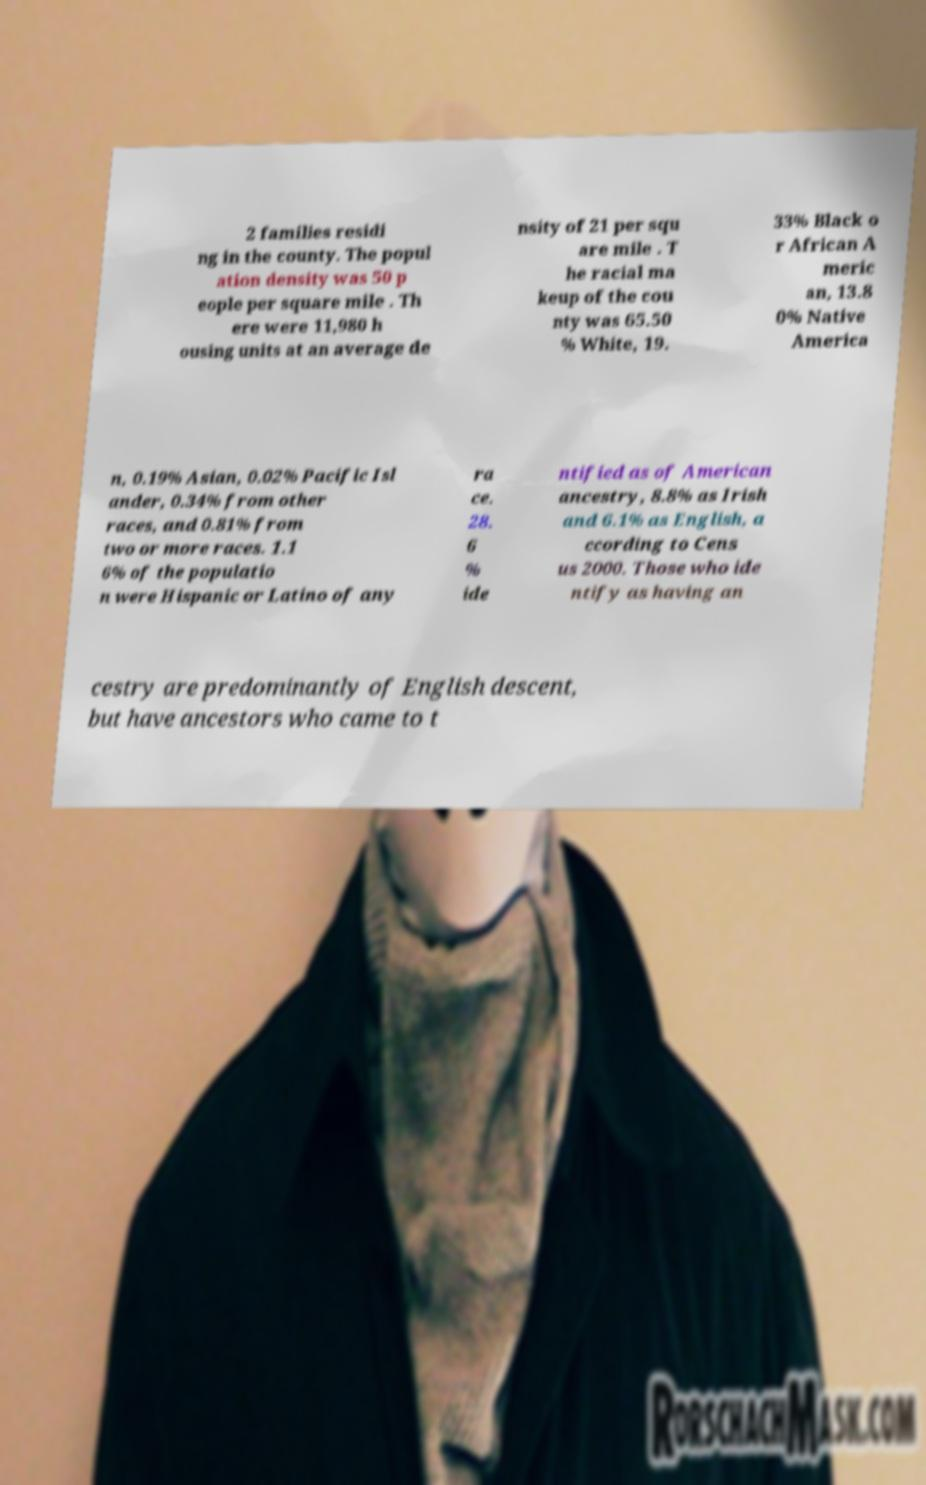Please identify and transcribe the text found in this image. 2 families residi ng in the county. The popul ation density was 50 p eople per square mile . Th ere were 11,980 h ousing units at an average de nsity of 21 per squ are mile . T he racial ma keup of the cou nty was 65.50 % White, 19. 33% Black o r African A meric an, 13.8 0% Native America n, 0.19% Asian, 0.02% Pacific Isl ander, 0.34% from other races, and 0.81% from two or more races. 1.1 6% of the populatio n were Hispanic or Latino of any ra ce. 28. 6 % ide ntified as of American ancestry, 8.8% as Irish and 6.1% as English, a ccording to Cens us 2000. Those who ide ntify as having an cestry are predominantly of English descent, but have ancestors who came to t 